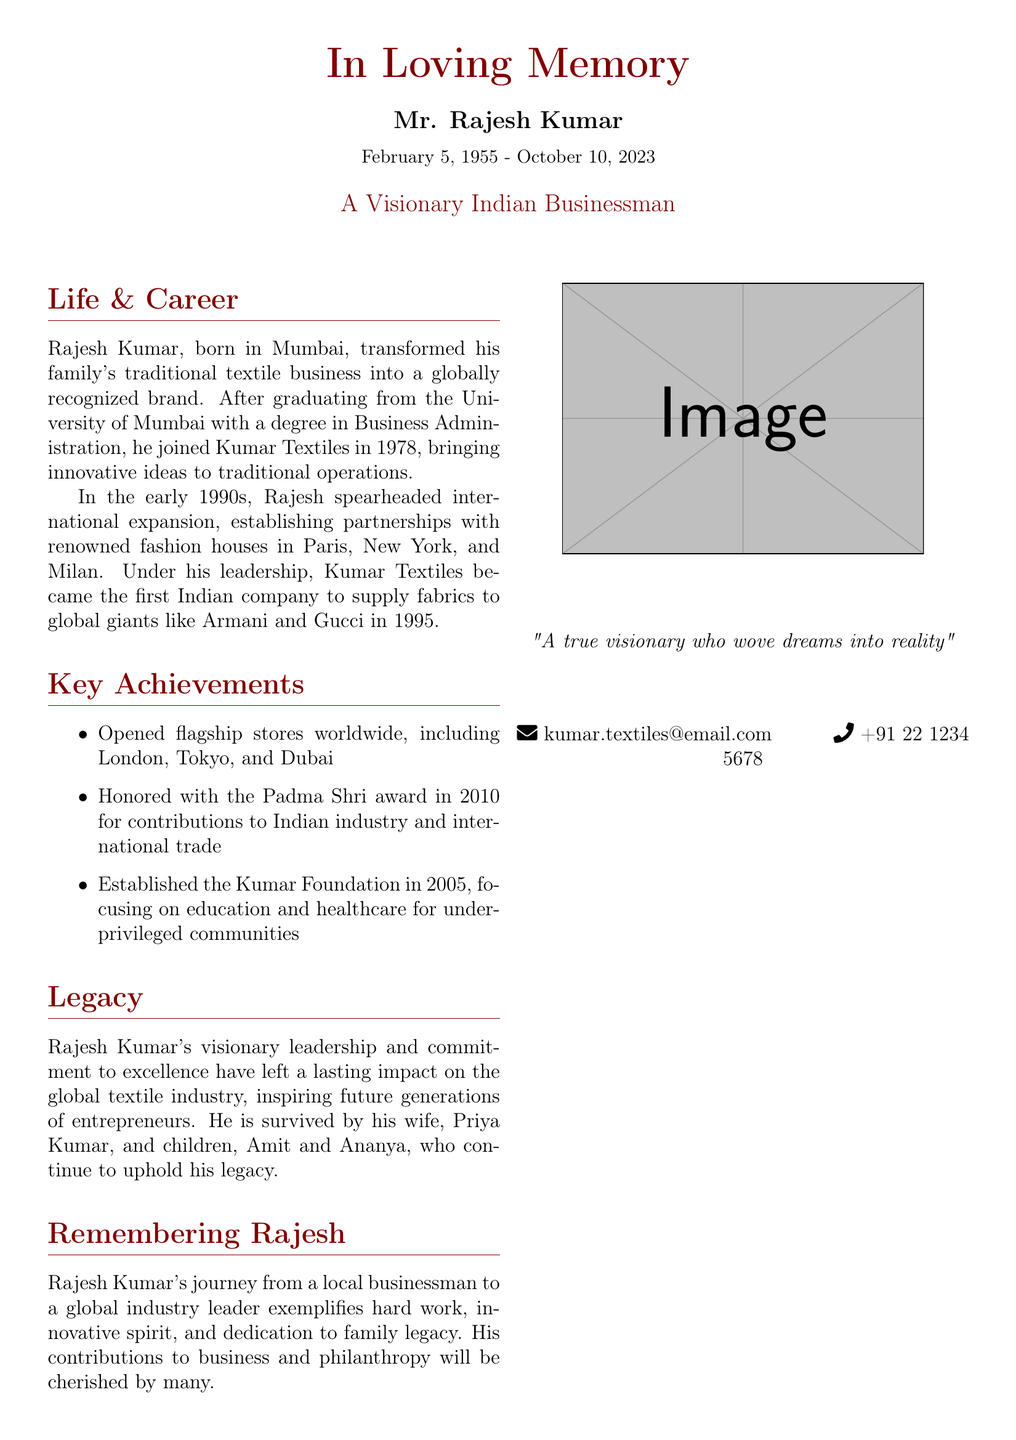What was Mr. Rajesh Kumar's date of birth? The date of birth of Mr. Rajesh Kumar is mentioned in the document as February 5, 1955.
Answer: February 5, 1955 Which award did Rajesh Kumar receive in 2010? The document specifies that Rajesh Kumar was honored with the Padma Shri award in 2010.
Answer: Padma Shri What is the name of the foundation established by Rajesh Kumar? The foundation mentioned in the obituary is the Kumar Foundation.
Answer: Kumar Foundation What year did Rajesh Kumar join Kumar Textiles? The document states that Rajesh Kumar joined Kumar Textiles in 1978.
Answer: 1978 In which cities did Rajesh Kumar open flagship stores? The document lists London, Tokyo, and Dubai as cities where flagship stores were opened.
Answer: London, Tokyo, Dubai What international fashion houses did Rajesh Kumar partner with? The fashion houses mentioned in the document include Armani and Gucci.
Answer: Armani and Gucci Who are the survivors mentioned in the obituary? The survivors listed are his wife Priya Kumar and children Amit and Ananya.
Answer: Priya Kumar, Amit, Ananya What was Rajesh Kumar's educational background? The document states that he graduated from the University of Mumbai with a degree in Business Administration.
Answer: University of Mumbai, Business Administration When was the Kumar Foundation established? The establishment year of the Kumar Foundation mentioned in the document is 2005.
Answer: 2005 